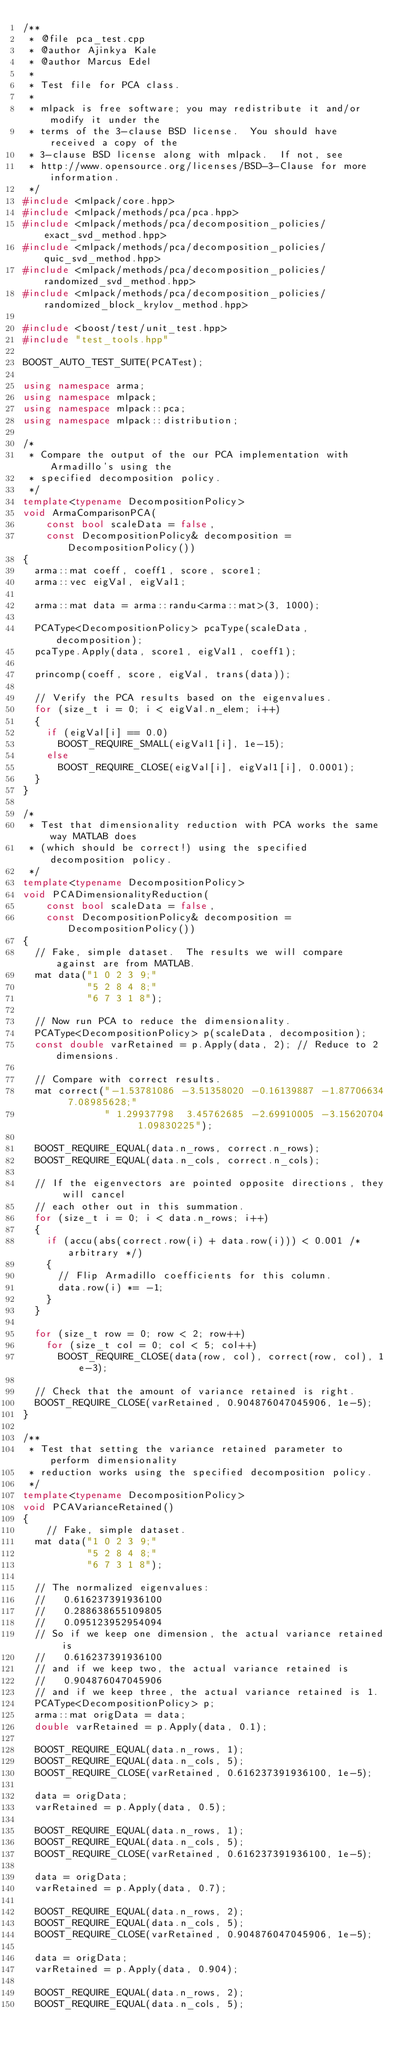<code> <loc_0><loc_0><loc_500><loc_500><_C++_>/**
 * @file pca_test.cpp
 * @author Ajinkya Kale
 * @author Marcus Edel
 *
 * Test file for PCA class.
 *
 * mlpack is free software; you may redistribute it and/or modify it under the
 * terms of the 3-clause BSD license.  You should have received a copy of the
 * 3-clause BSD license along with mlpack.  If not, see
 * http://www.opensource.org/licenses/BSD-3-Clause for more information.
 */
#include <mlpack/core.hpp>
#include <mlpack/methods/pca/pca.hpp>
#include <mlpack/methods/pca/decomposition_policies/exact_svd_method.hpp>
#include <mlpack/methods/pca/decomposition_policies/quic_svd_method.hpp>
#include <mlpack/methods/pca/decomposition_policies/randomized_svd_method.hpp>
#include <mlpack/methods/pca/decomposition_policies/randomized_block_krylov_method.hpp>

#include <boost/test/unit_test.hpp>
#include "test_tools.hpp"

BOOST_AUTO_TEST_SUITE(PCATest);

using namespace arma;
using namespace mlpack;
using namespace mlpack::pca;
using namespace mlpack::distribution;

/*
 * Compare the output of the our PCA implementation with Armadillo's using the
 * specified decomposition policy.
 */
template<typename DecompositionPolicy>
void ArmaComparisonPCA(
    const bool scaleData = false,
    const DecompositionPolicy& decomposition = DecompositionPolicy())
{
  arma::mat coeff, coeff1, score, score1;
  arma::vec eigVal, eigVal1;

  arma::mat data = arma::randu<arma::mat>(3, 1000);

  PCAType<DecompositionPolicy> pcaType(scaleData, decomposition);
  pcaType.Apply(data, score1, eigVal1, coeff1);

  princomp(coeff, score, eigVal, trans(data));

  // Verify the PCA results based on the eigenvalues.
  for (size_t i = 0; i < eigVal.n_elem; i++)
  {
    if (eigVal[i] == 0.0)
      BOOST_REQUIRE_SMALL(eigVal1[i], 1e-15);
    else
      BOOST_REQUIRE_CLOSE(eigVal[i], eigVal1[i], 0.0001);
  }
}

/*
 * Test that dimensionality reduction with PCA works the same way MATLAB does
 * (which should be correct!) using the specified decomposition policy.
 */
template<typename DecompositionPolicy>
void PCADimensionalityReduction(
    const bool scaleData = false,
    const DecompositionPolicy& decomposition = DecompositionPolicy())
{
  // Fake, simple dataset.  The results we will compare against are from MATLAB.
  mat data("1 0 2 3 9;"
           "5 2 8 4 8;"
           "6 7 3 1 8");

  // Now run PCA to reduce the dimensionality.
  PCAType<DecompositionPolicy> p(scaleData, decomposition);
  const double varRetained = p.Apply(data, 2); // Reduce to 2 dimensions.

  // Compare with correct results.
  mat correct("-1.53781086 -3.51358020 -0.16139887 -1.87706634  7.08985628;"
              " 1.29937798  3.45762685 -2.69910005 -3.15620704  1.09830225");

  BOOST_REQUIRE_EQUAL(data.n_rows, correct.n_rows);
  BOOST_REQUIRE_EQUAL(data.n_cols, correct.n_cols);

  // If the eigenvectors are pointed opposite directions, they will cancel
  // each other out in this summation.
  for (size_t i = 0; i < data.n_rows; i++)
  {
    if (accu(abs(correct.row(i) + data.row(i))) < 0.001 /* arbitrary */)
    {
      // Flip Armadillo coefficients for this column.
      data.row(i) *= -1;
    }
  }

  for (size_t row = 0; row < 2; row++)
    for (size_t col = 0; col < 5; col++)
      BOOST_REQUIRE_CLOSE(data(row, col), correct(row, col), 1e-3);

  // Check that the amount of variance retained is right.
  BOOST_REQUIRE_CLOSE(varRetained, 0.904876047045906, 1e-5);
}

/**
 * Test that setting the variance retained parameter to perform dimensionality
 * reduction works using the specified decomposition policy.
 */
template<typename DecompositionPolicy>
void PCAVarianceRetained()
{
    // Fake, simple dataset.
  mat data("1 0 2 3 9;"
           "5 2 8 4 8;"
           "6 7 3 1 8");

  // The normalized eigenvalues:
  //   0.616237391936100
  //   0.288638655109805
  //   0.095123952954094
  // So if we keep one dimension, the actual variance retained is
  //   0.616237391936100
  // and if we keep two, the actual variance retained is
  //   0.904876047045906
  // and if we keep three, the actual variance retained is 1.
  PCAType<DecompositionPolicy> p;
  arma::mat origData = data;
  double varRetained = p.Apply(data, 0.1);

  BOOST_REQUIRE_EQUAL(data.n_rows, 1);
  BOOST_REQUIRE_EQUAL(data.n_cols, 5);
  BOOST_REQUIRE_CLOSE(varRetained, 0.616237391936100, 1e-5);

  data = origData;
  varRetained = p.Apply(data, 0.5);

  BOOST_REQUIRE_EQUAL(data.n_rows, 1);
  BOOST_REQUIRE_EQUAL(data.n_cols, 5);
  BOOST_REQUIRE_CLOSE(varRetained, 0.616237391936100, 1e-5);

  data = origData;
  varRetained = p.Apply(data, 0.7);

  BOOST_REQUIRE_EQUAL(data.n_rows, 2);
  BOOST_REQUIRE_EQUAL(data.n_cols, 5);
  BOOST_REQUIRE_CLOSE(varRetained, 0.904876047045906, 1e-5);

  data = origData;
  varRetained = p.Apply(data, 0.904);

  BOOST_REQUIRE_EQUAL(data.n_rows, 2);
  BOOST_REQUIRE_EQUAL(data.n_cols, 5);</code> 